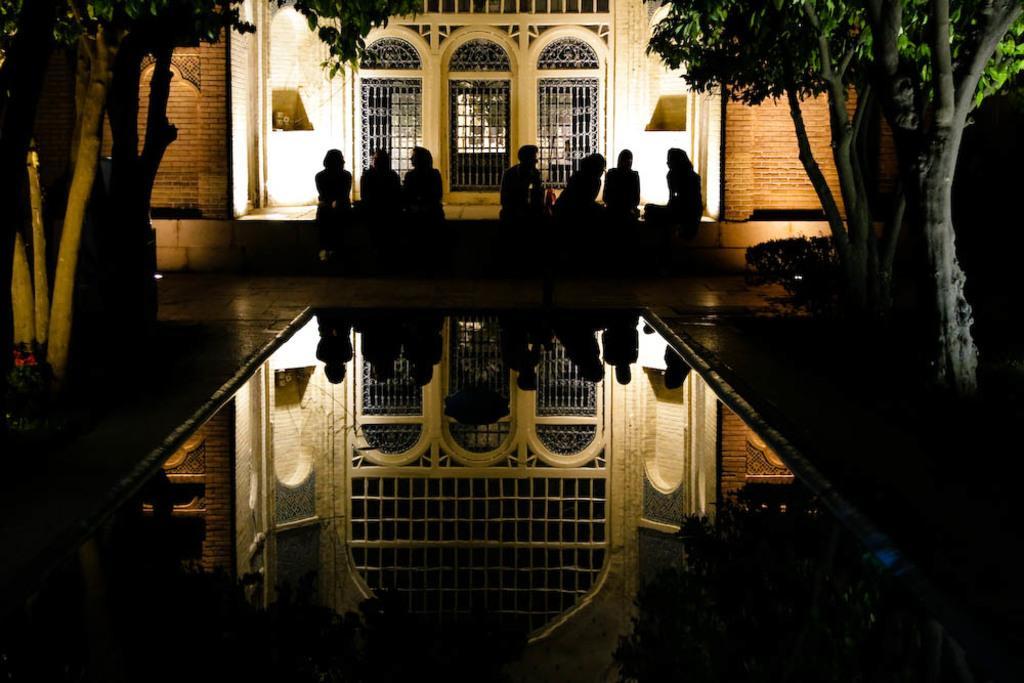Could you give a brief overview of what you see in this image? In the foreground of the picture there is a water pool. On the left there are trees. On the right there are trees and plants. In the center of the picture there are group of people sitting. In the background there is a building, we can see brick walls, windows and door. 